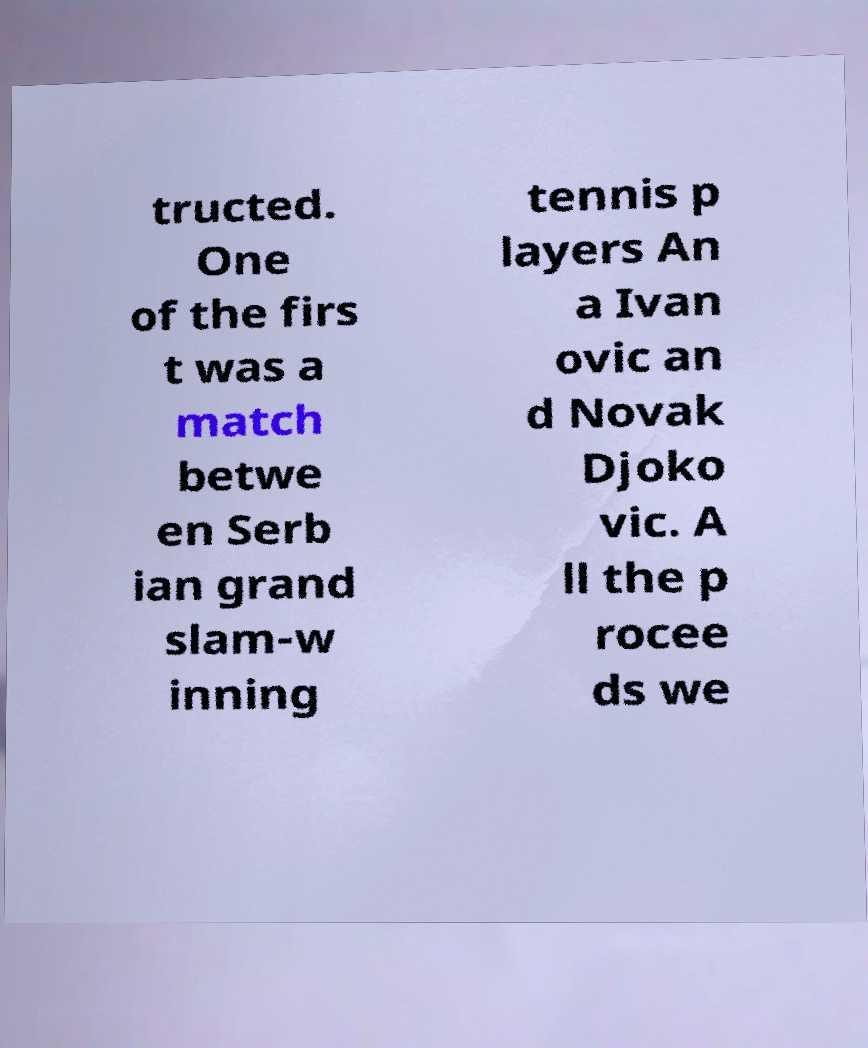Can you read and provide the text displayed in the image?This photo seems to have some interesting text. Can you extract and type it out for me? tructed. One of the firs t was a match betwe en Serb ian grand slam-w inning tennis p layers An a Ivan ovic an d Novak Djoko vic. A ll the p rocee ds we 